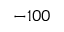<formula> <loc_0><loc_0><loc_500><loc_500>- 1 0 0</formula> 